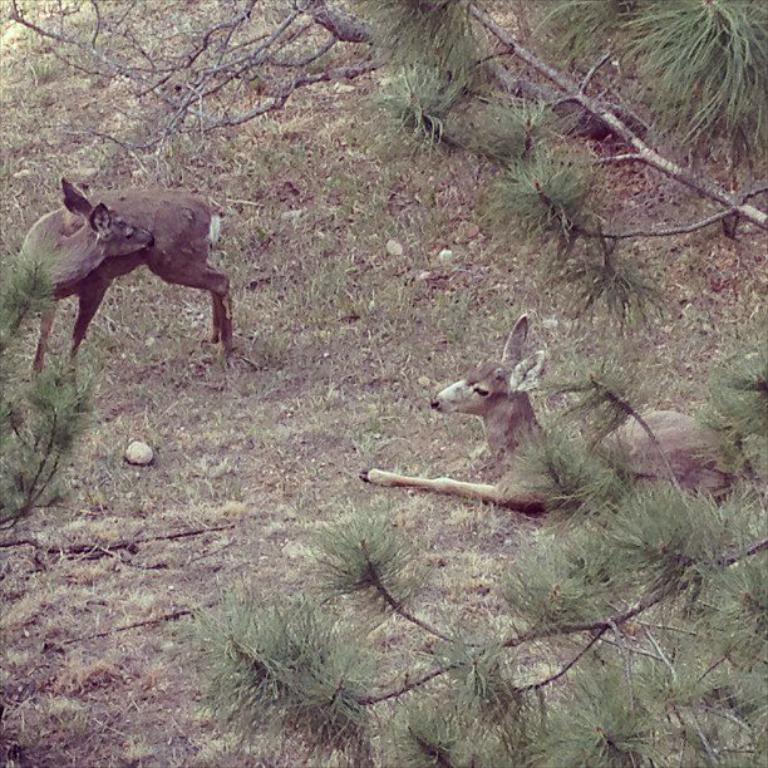Can you describe this image briefly? There is deer on the right and left side of the image and there is greenery around the area. 